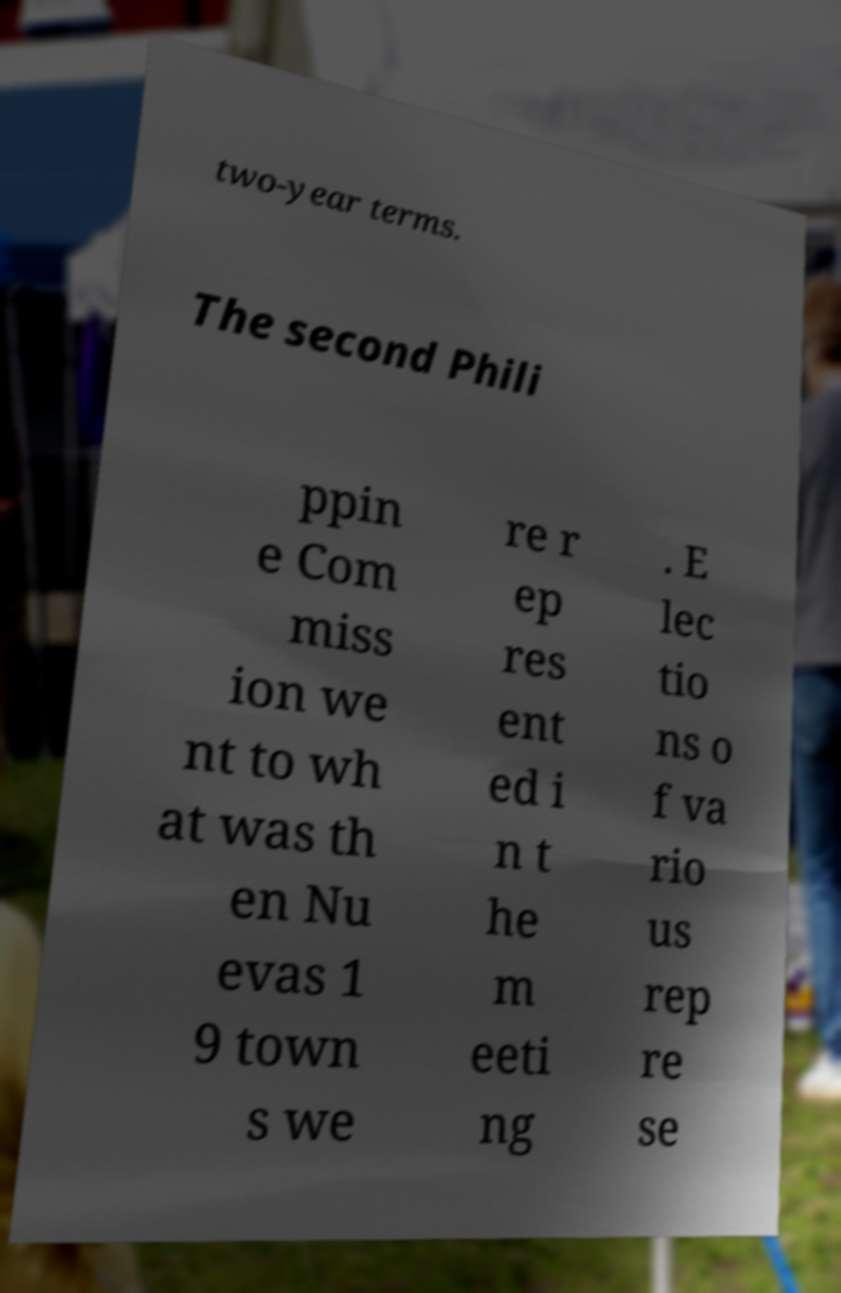Can you accurately transcribe the text from the provided image for me? two-year terms. The second Phili ppin e Com miss ion we nt to wh at was th en Nu evas 1 9 town s we re r ep res ent ed i n t he m eeti ng . E lec tio ns o f va rio us rep re se 